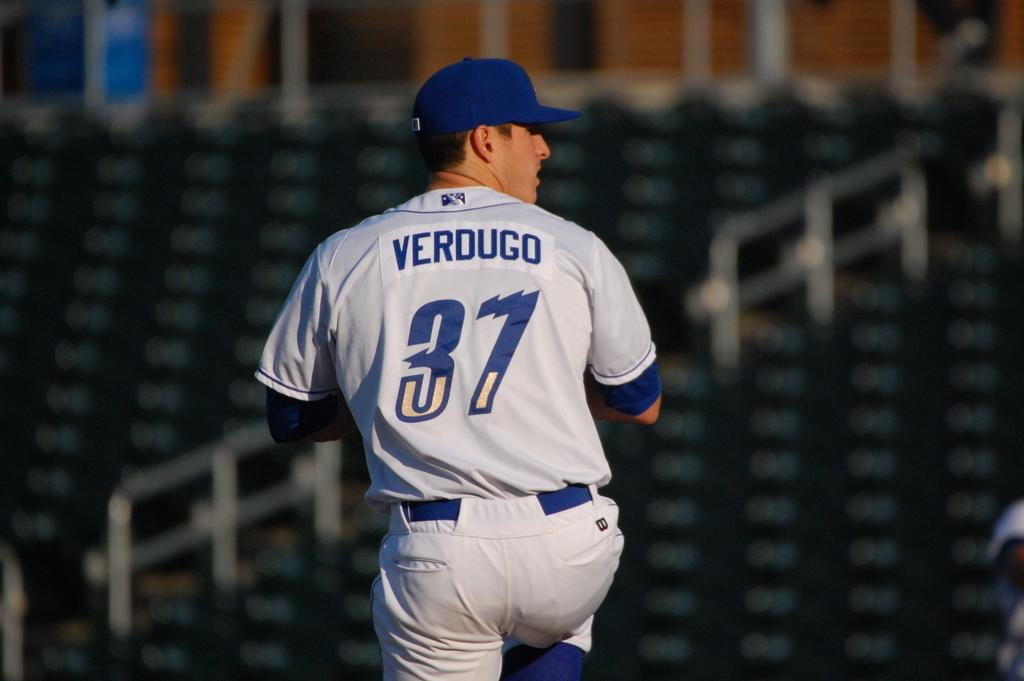<image>
Present a compact description of the photo's key features. The players name is Verdugo written in blue 